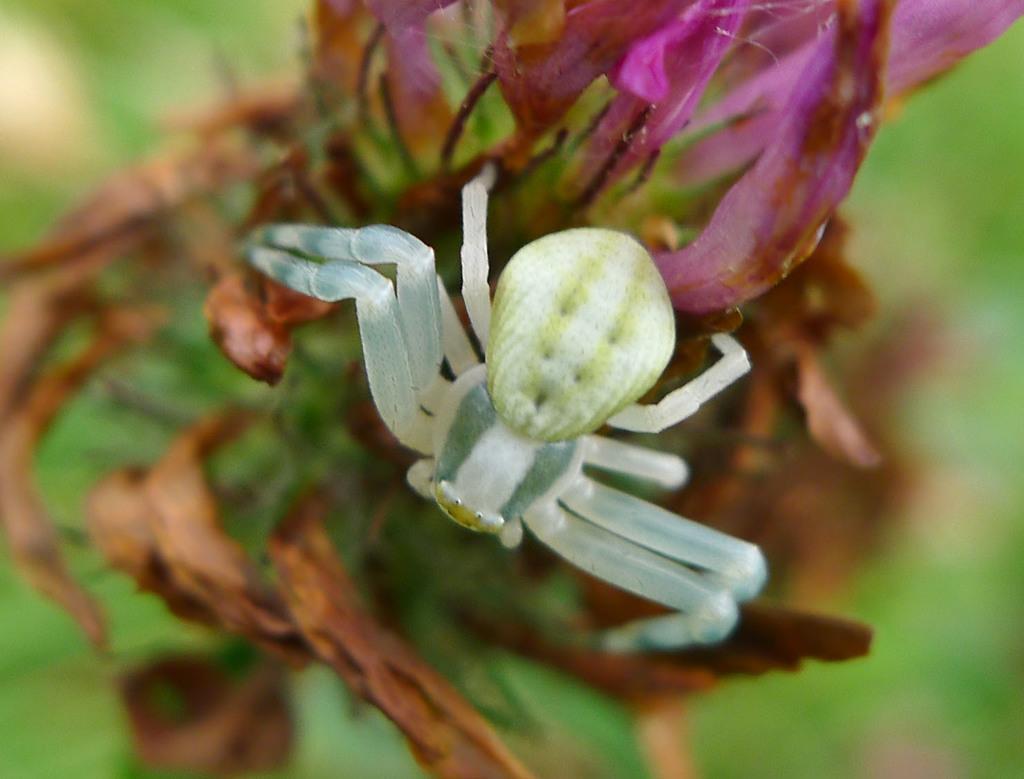In one or two sentences, can you explain what this image depicts? In this picture we can see an insect and a flower in the front, there is a blurry background. 